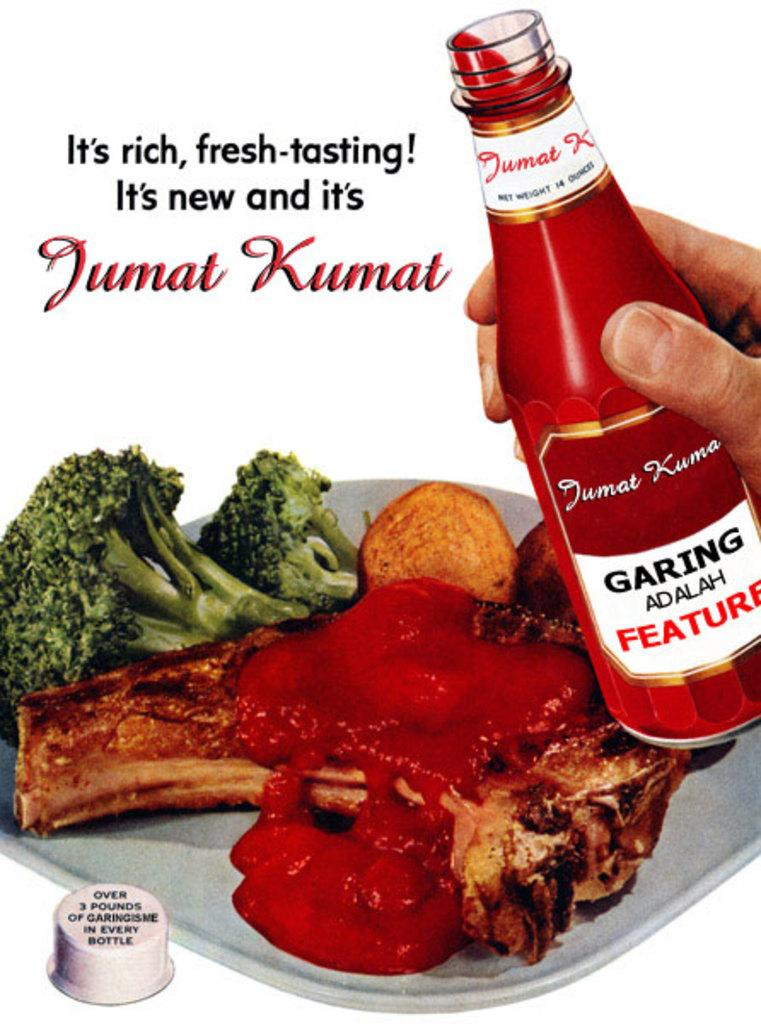<image>
Present a compact description of the photo's key features. A advertisement for a sauce called Jumat Kumat. 